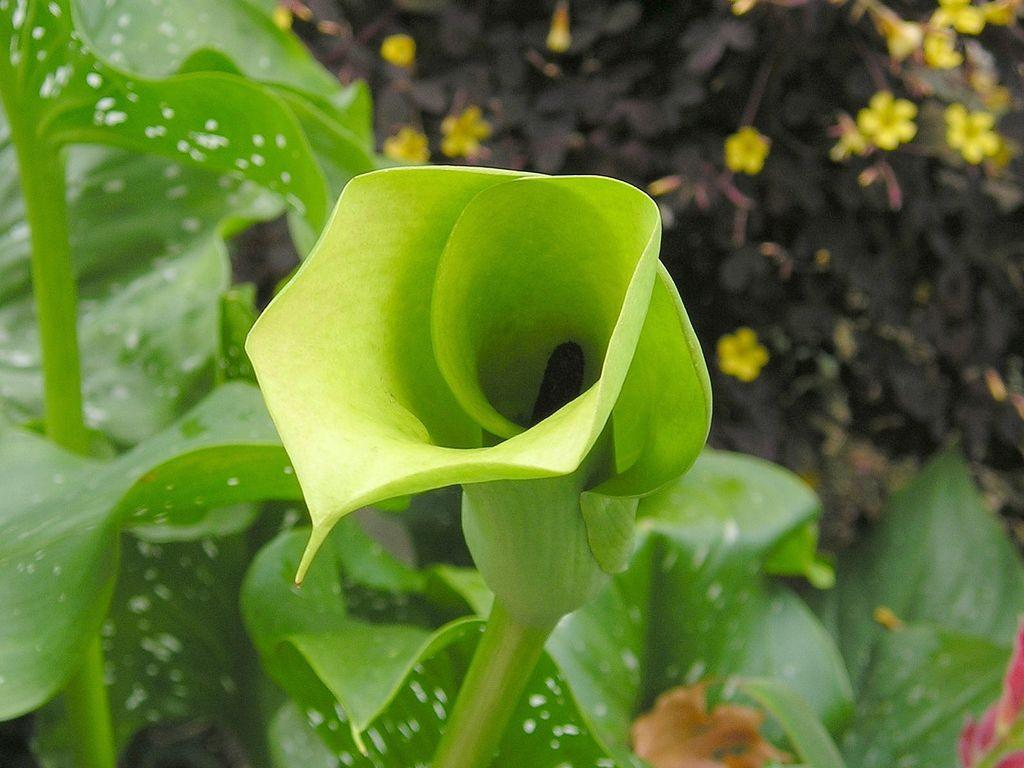What type of vegetation is present in the image? There are green leaves in the image. What color are the followers in the image? There are yellow followers in the image. What is the color of the black object in the image? There is a black object in the image. What type of appliance is being requested in the image? There is no appliance being requested in the image; it only features green leaves, yellow followers, and a black object. What mode of transport is visible in the image? There is no mode of transport visible in the image. 